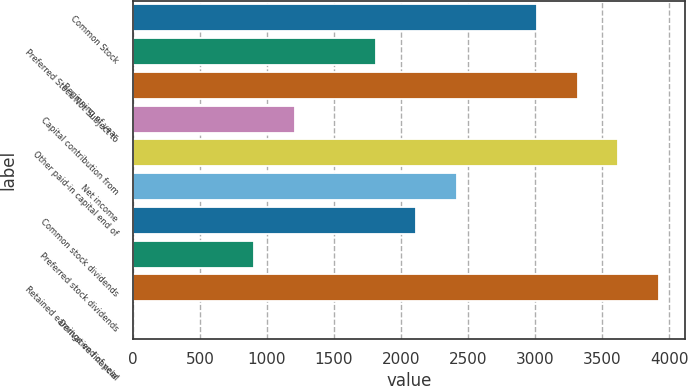Convert chart. <chart><loc_0><loc_0><loc_500><loc_500><bar_chart><fcel>Common Stock<fcel>Preferred Stock Not Subject to<fcel>Beginning of year<fcel>Capital contribution from<fcel>Other paid-in capital end of<fcel>Net income<fcel>Common stock dividends<fcel>Preferred stock dividends<fcel>Retained earnings end of year<fcel>Derivative financial<nl><fcel>3016<fcel>1810.4<fcel>3317.4<fcel>1207.6<fcel>3618.8<fcel>2413.2<fcel>2111.8<fcel>906.2<fcel>3920.2<fcel>2<nl></chart> 